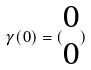<formula> <loc_0><loc_0><loc_500><loc_500>\gamma ( 0 ) = ( \begin{matrix} 0 \\ 0 \end{matrix} )</formula> 